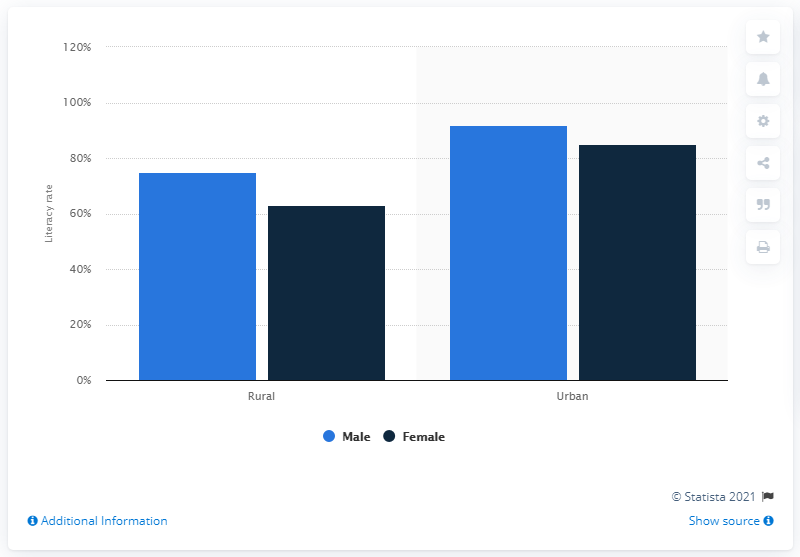Give some essential details in this illustration. According to the data from 2011, the literacy rate among males living in the urban region of Assam was 92%. 